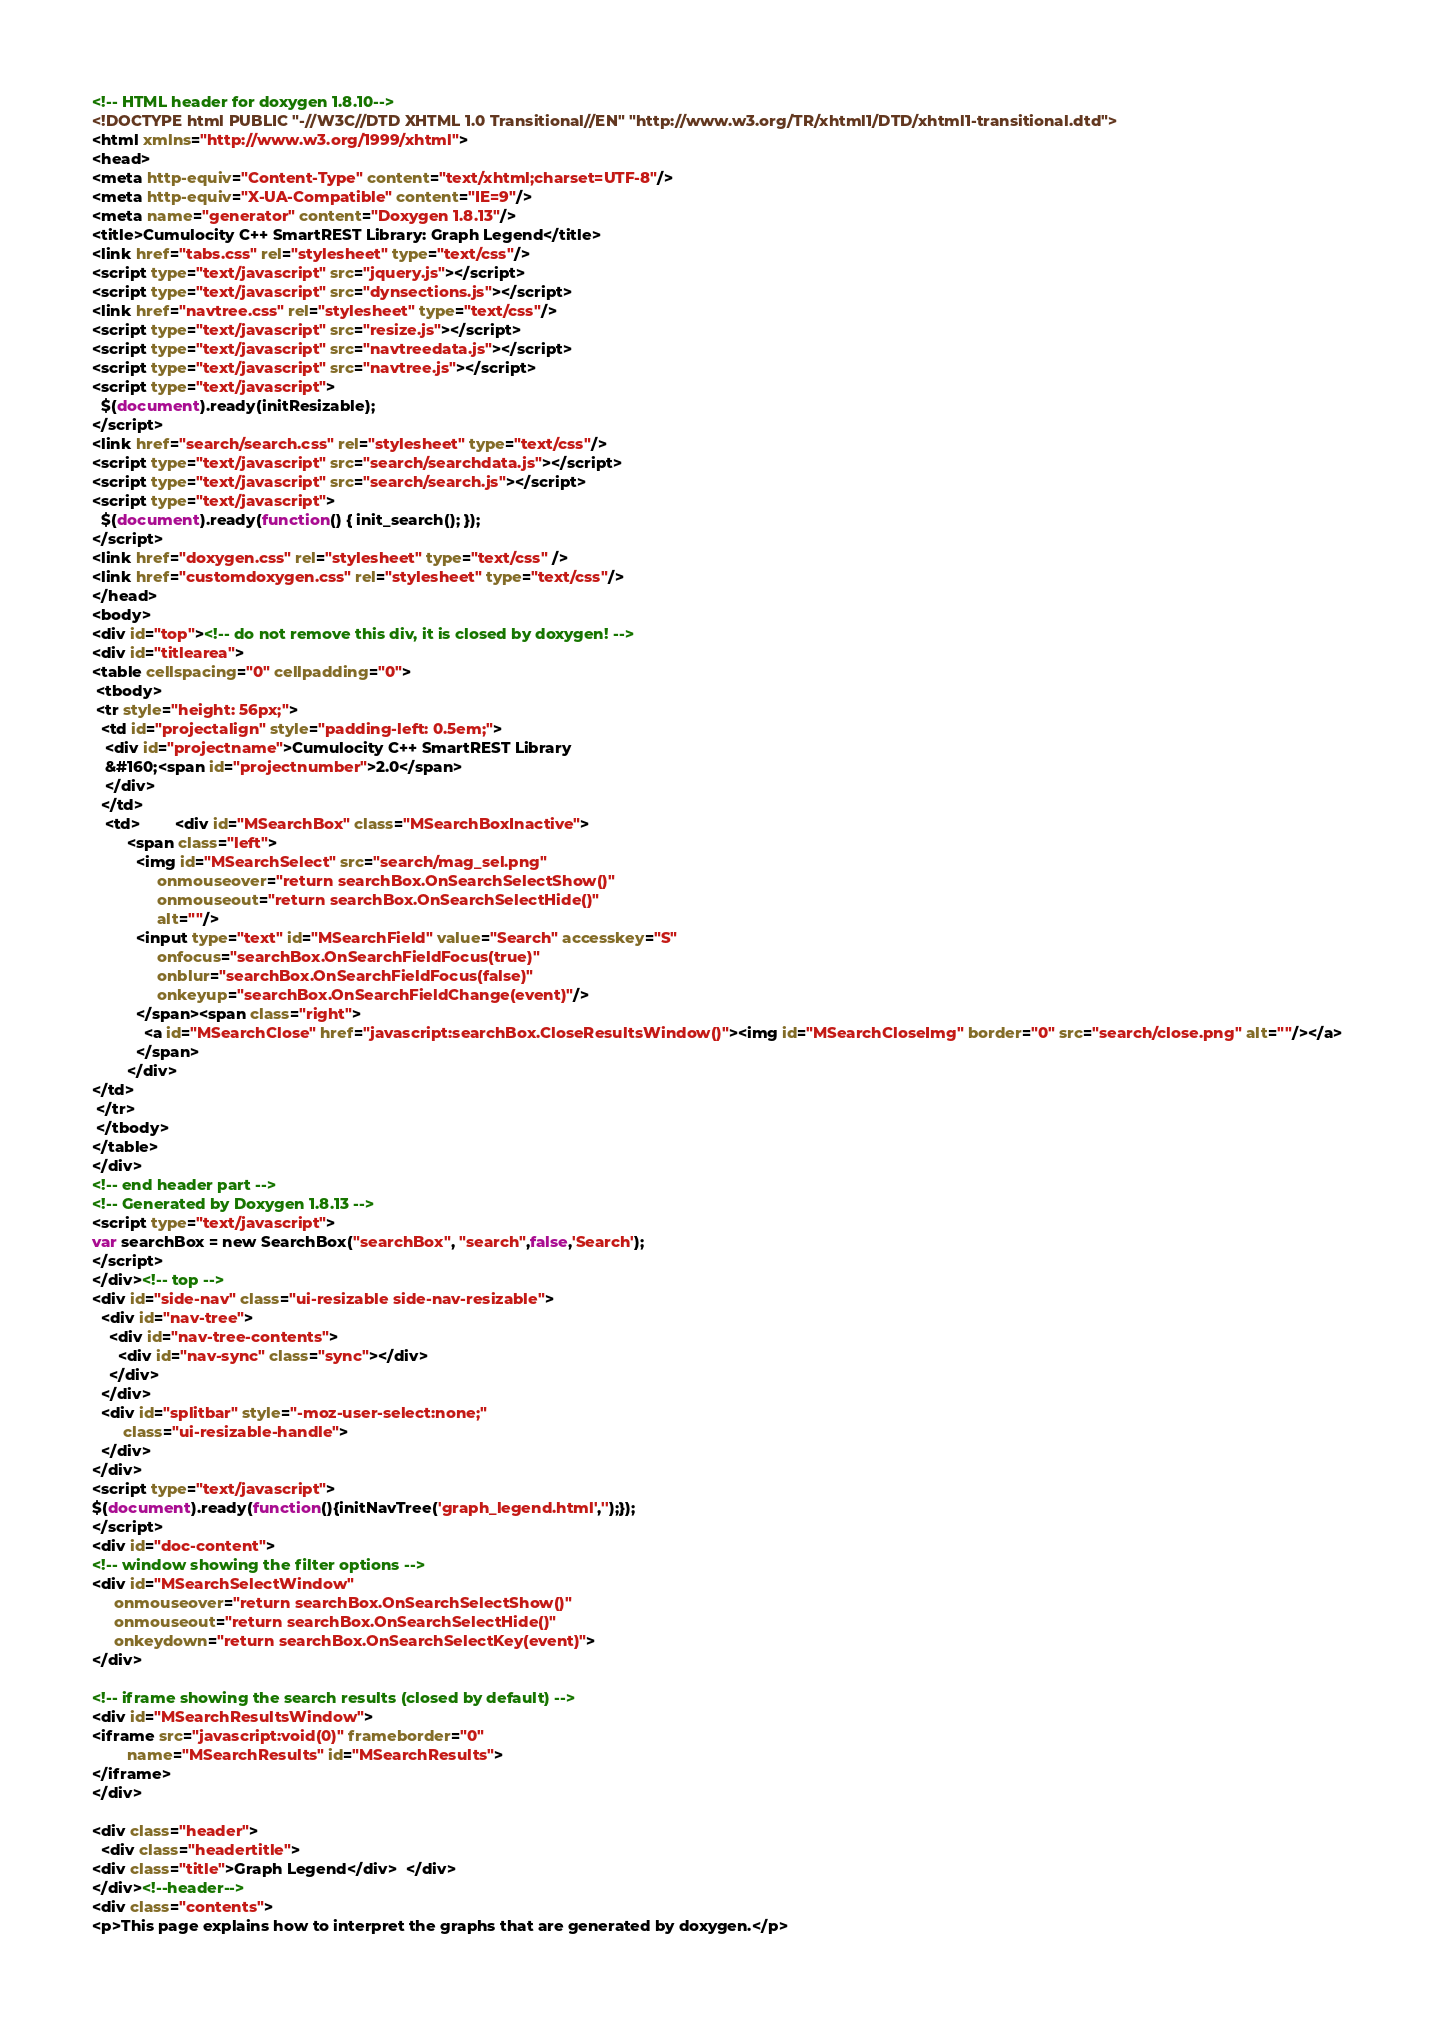<code> <loc_0><loc_0><loc_500><loc_500><_HTML_><!-- HTML header for doxygen 1.8.10-->
<!DOCTYPE html PUBLIC "-//W3C//DTD XHTML 1.0 Transitional//EN" "http://www.w3.org/TR/xhtml1/DTD/xhtml1-transitional.dtd">
<html xmlns="http://www.w3.org/1999/xhtml">
<head>
<meta http-equiv="Content-Type" content="text/xhtml;charset=UTF-8"/>
<meta http-equiv="X-UA-Compatible" content="IE=9"/>
<meta name="generator" content="Doxygen 1.8.13"/>
<title>Cumulocity C++ SmartREST Library: Graph Legend</title>
<link href="tabs.css" rel="stylesheet" type="text/css"/>
<script type="text/javascript" src="jquery.js"></script>
<script type="text/javascript" src="dynsections.js"></script>
<link href="navtree.css" rel="stylesheet" type="text/css"/>
<script type="text/javascript" src="resize.js"></script>
<script type="text/javascript" src="navtreedata.js"></script>
<script type="text/javascript" src="navtree.js"></script>
<script type="text/javascript">
  $(document).ready(initResizable);
</script>
<link href="search/search.css" rel="stylesheet" type="text/css"/>
<script type="text/javascript" src="search/searchdata.js"></script>
<script type="text/javascript" src="search/search.js"></script>
<script type="text/javascript">
  $(document).ready(function() { init_search(); });
</script>
<link href="doxygen.css" rel="stylesheet" type="text/css" />
<link href="customdoxygen.css" rel="stylesheet" type="text/css"/>
</head>
<body>
<div id="top"><!-- do not remove this div, it is closed by doxygen! -->
<div id="titlearea">
<table cellspacing="0" cellpadding="0">
 <tbody>
 <tr style="height: 56px;">
  <td id="projectalign" style="padding-left: 0.5em;">
   <div id="projectname">Cumulocity C++ SmartREST Library
   &#160;<span id="projectnumber">2.0</span>
   </div>
  </td>
   <td>        <div id="MSearchBox" class="MSearchBoxInactive">
        <span class="left">
          <img id="MSearchSelect" src="search/mag_sel.png"
               onmouseover="return searchBox.OnSearchSelectShow()"
               onmouseout="return searchBox.OnSearchSelectHide()"
               alt=""/>
          <input type="text" id="MSearchField" value="Search" accesskey="S"
               onfocus="searchBox.OnSearchFieldFocus(true)" 
               onblur="searchBox.OnSearchFieldFocus(false)" 
               onkeyup="searchBox.OnSearchFieldChange(event)"/>
          </span><span class="right">
            <a id="MSearchClose" href="javascript:searchBox.CloseResultsWindow()"><img id="MSearchCloseImg" border="0" src="search/close.png" alt=""/></a>
          </span>
        </div>
</td>
 </tr>
 </tbody>
</table>
</div>
<!-- end header part -->
<!-- Generated by Doxygen 1.8.13 -->
<script type="text/javascript">
var searchBox = new SearchBox("searchBox", "search",false,'Search');
</script>
</div><!-- top -->
<div id="side-nav" class="ui-resizable side-nav-resizable">
  <div id="nav-tree">
    <div id="nav-tree-contents">
      <div id="nav-sync" class="sync"></div>
    </div>
  </div>
  <div id="splitbar" style="-moz-user-select:none;" 
       class="ui-resizable-handle">
  </div>
</div>
<script type="text/javascript">
$(document).ready(function(){initNavTree('graph_legend.html','');});
</script>
<div id="doc-content">
<!-- window showing the filter options -->
<div id="MSearchSelectWindow"
     onmouseover="return searchBox.OnSearchSelectShow()"
     onmouseout="return searchBox.OnSearchSelectHide()"
     onkeydown="return searchBox.OnSearchSelectKey(event)">
</div>

<!-- iframe showing the search results (closed by default) -->
<div id="MSearchResultsWindow">
<iframe src="javascript:void(0)" frameborder="0" 
        name="MSearchResults" id="MSearchResults">
</iframe>
</div>

<div class="header">
  <div class="headertitle">
<div class="title">Graph Legend</div>  </div>
</div><!--header-->
<div class="contents">
<p>This page explains how to interpret the graphs that are generated by doxygen.</p></code> 